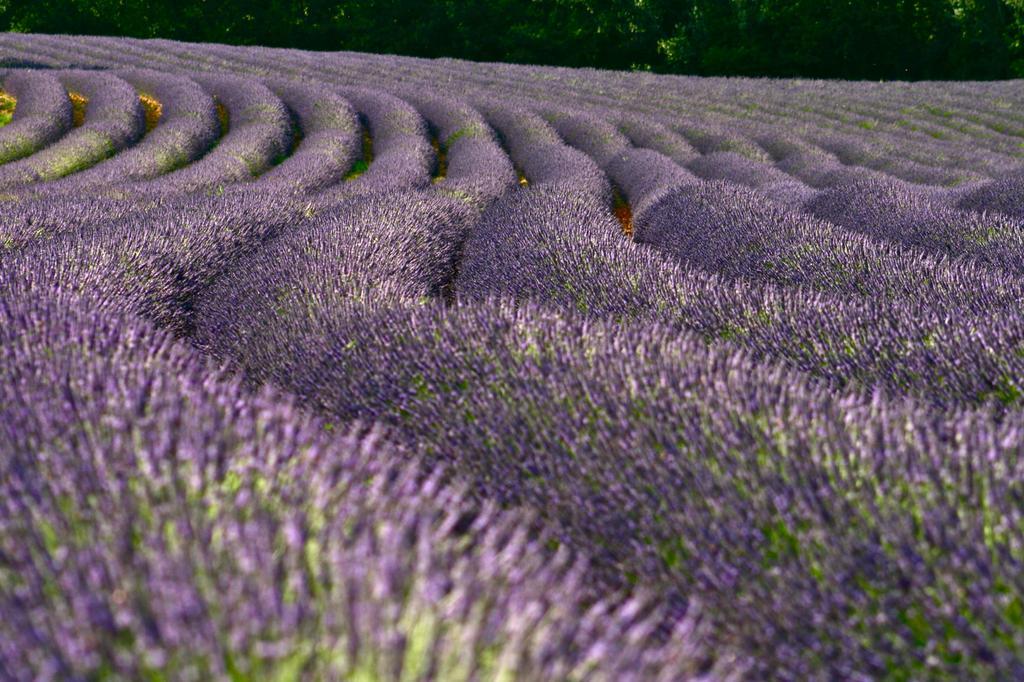Can you describe this image briefly? In this image we can see flower beds and trees in the background. 